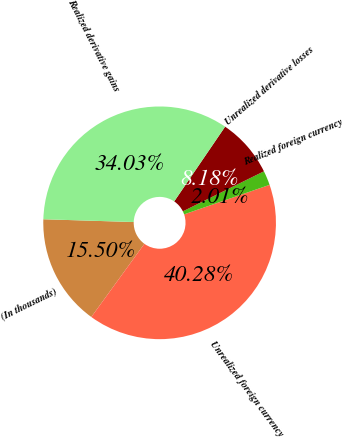Convert chart to OTSL. <chart><loc_0><loc_0><loc_500><loc_500><pie_chart><fcel>(In thousands)<fcel>Unrealized foreign currency<fcel>Realized foreign currency<fcel>Unrealized derivative losses<fcel>Realized derivative gains<nl><fcel>15.5%<fcel>40.28%<fcel>2.01%<fcel>8.18%<fcel>34.03%<nl></chart> 